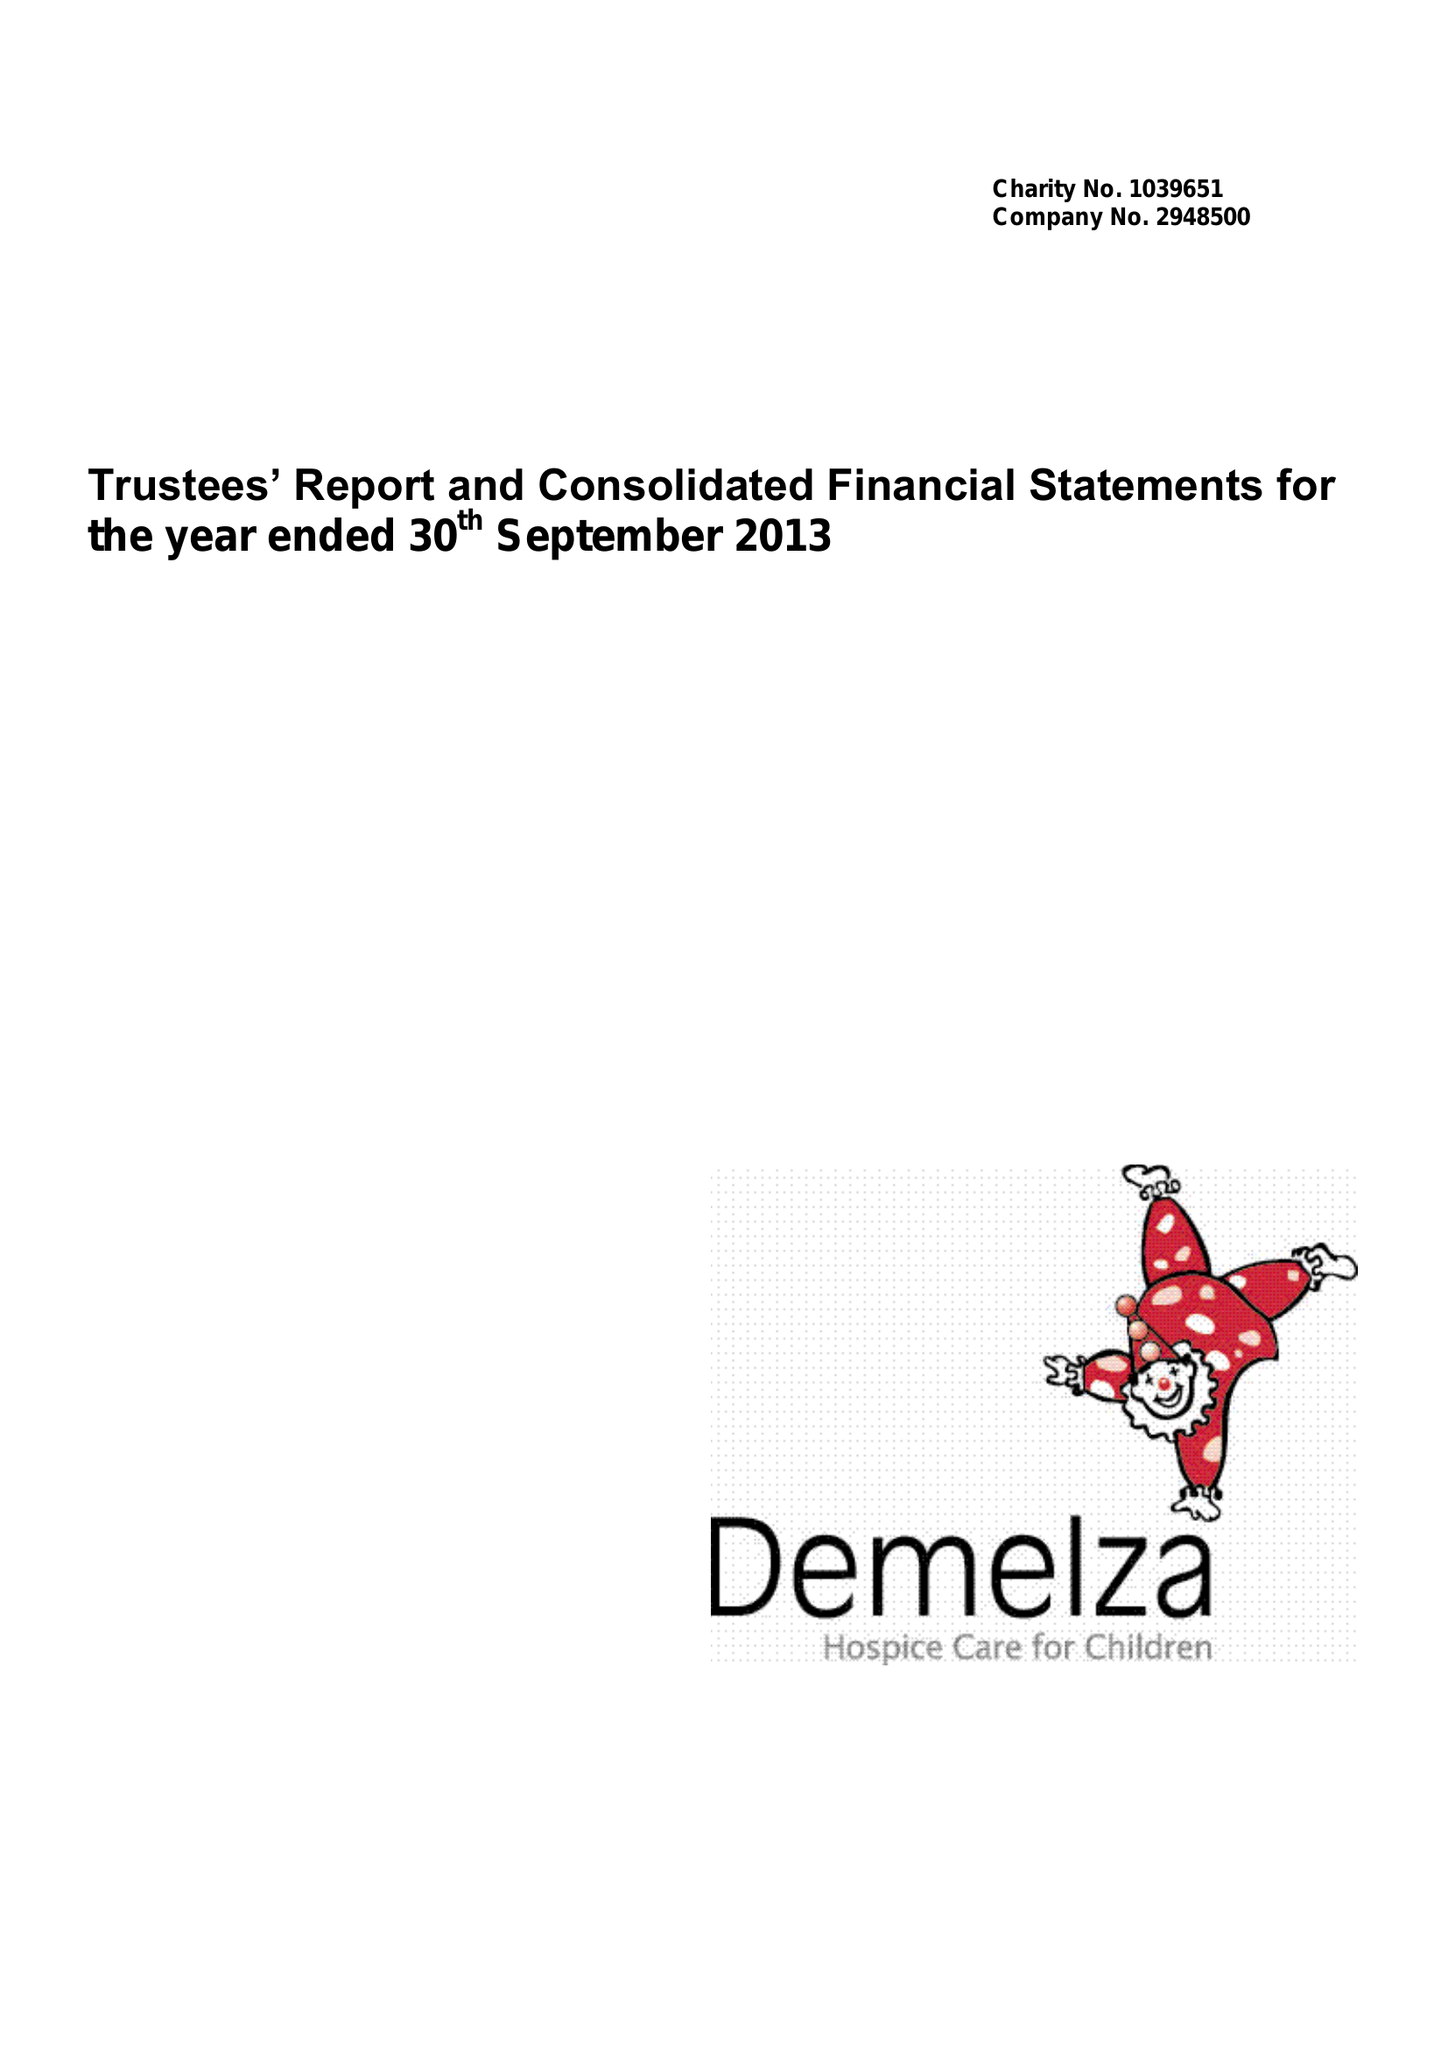What is the value for the report_date?
Answer the question using a single word or phrase. 2013-09-30 